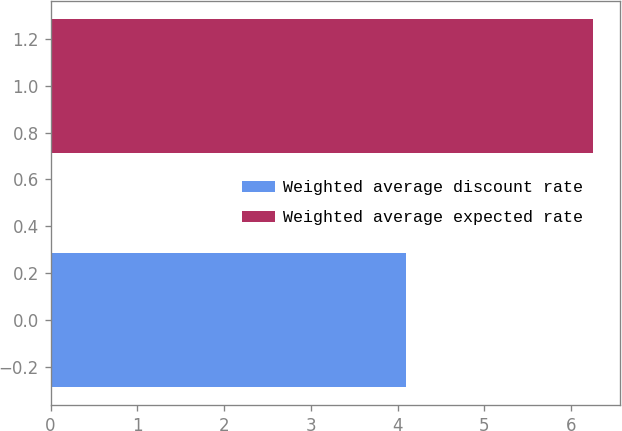Convert chart. <chart><loc_0><loc_0><loc_500><loc_500><bar_chart><fcel>Weighted average discount rate<fcel>Weighted average expected rate<nl><fcel>4.1<fcel>6.25<nl></chart> 